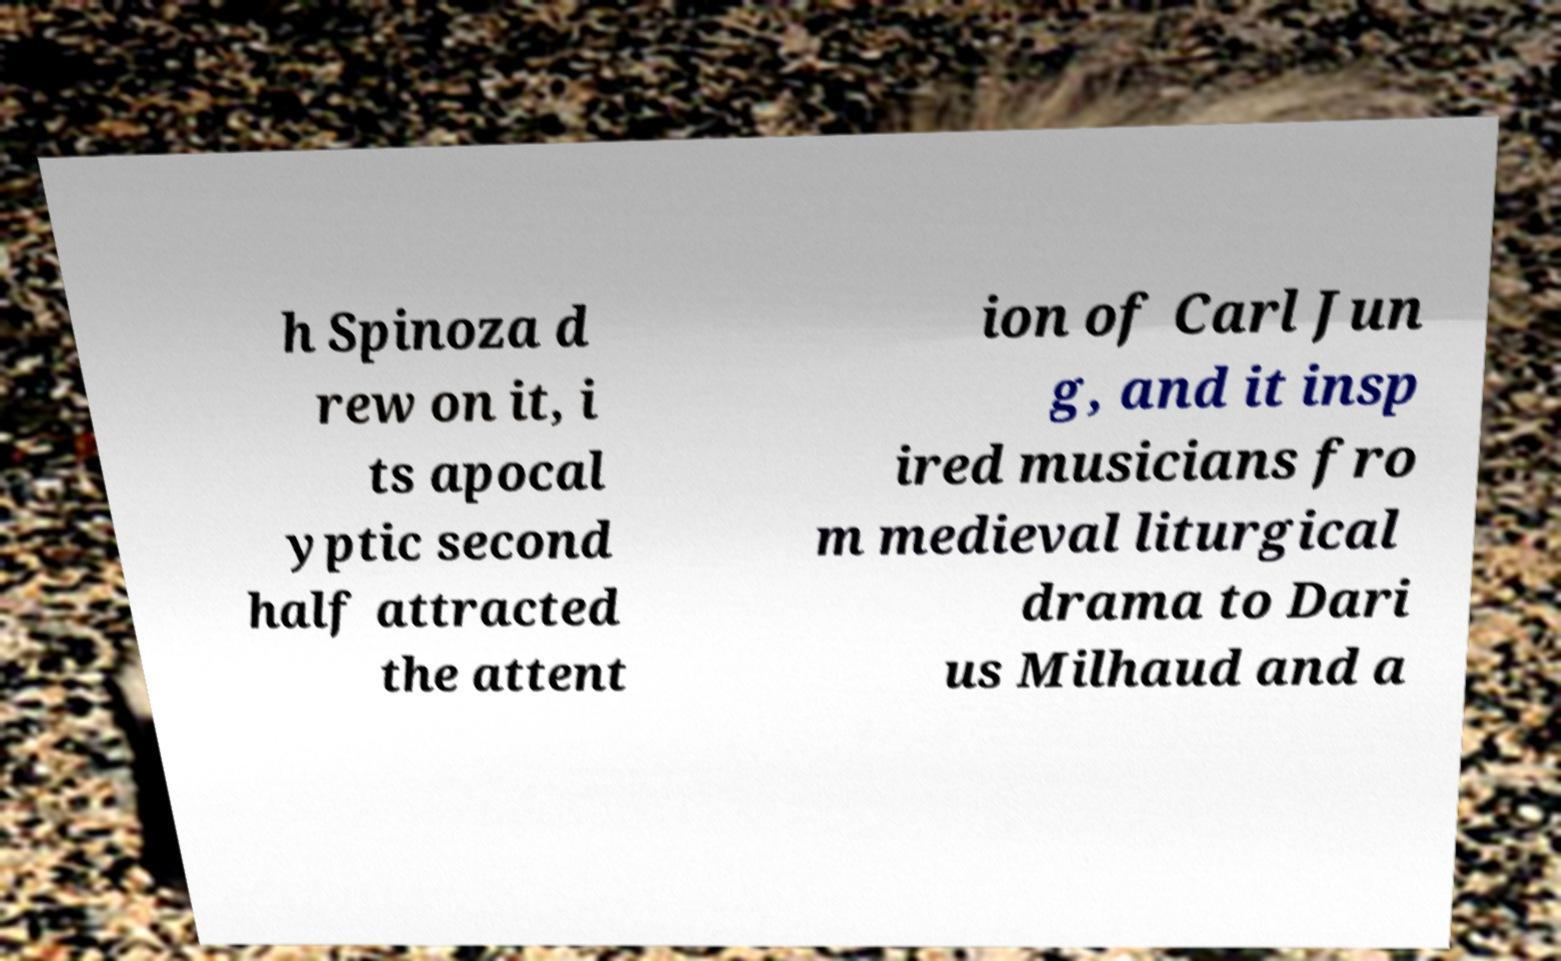Please identify and transcribe the text found in this image. h Spinoza d rew on it, i ts apocal yptic second half attracted the attent ion of Carl Jun g, and it insp ired musicians fro m medieval liturgical drama to Dari us Milhaud and a 